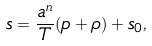<formula> <loc_0><loc_0><loc_500><loc_500>s = \frac { a ^ { n } } { T } ( p + \rho ) + s _ { 0 } ,</formula> 